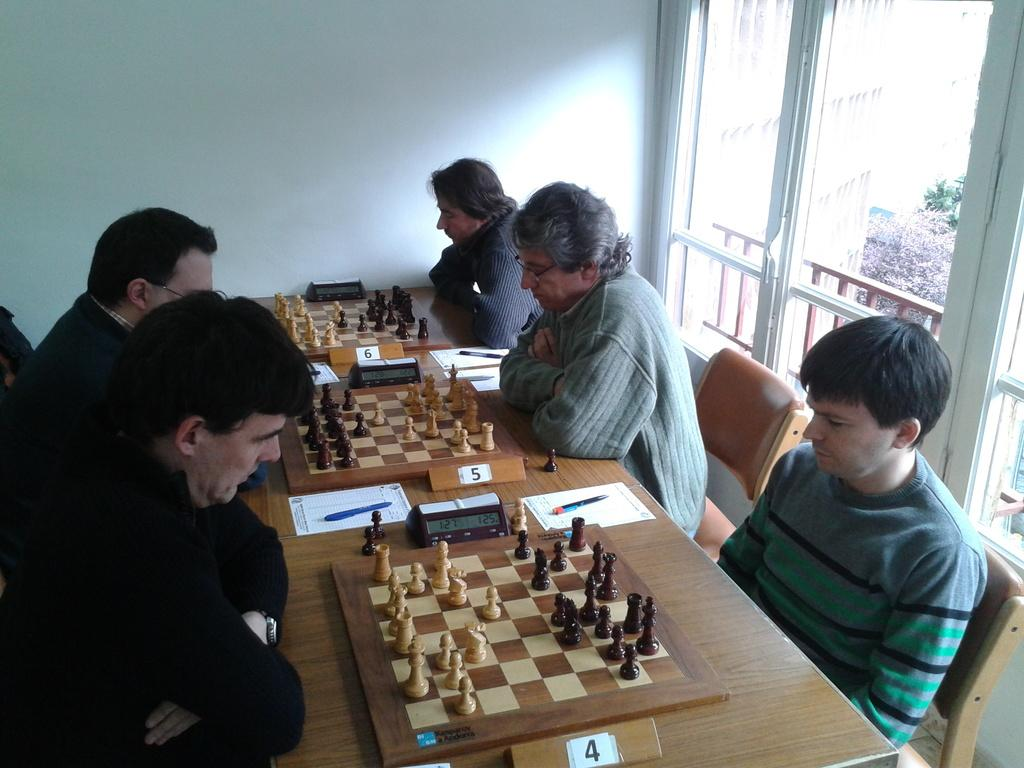What are the people in the image doing? The people in the image are playing chess. What is present on the table between the people? There is a paper, a pen, and a timer clock on the table. What might the paper and pen be used for? The paper and pen might be used for taking notes or recording moves during the chess game. What is the purpose of the timer clock? The timer clock is likely used to keep track of time during the chess game. What type of humor can be seen in the image? There is no humor present in the image; it depicts people playing chess. What is the temper of the chess pieces in the image? There are no emotions or temper displayed by the chess pieces in the image, as they are inanimate objects. 